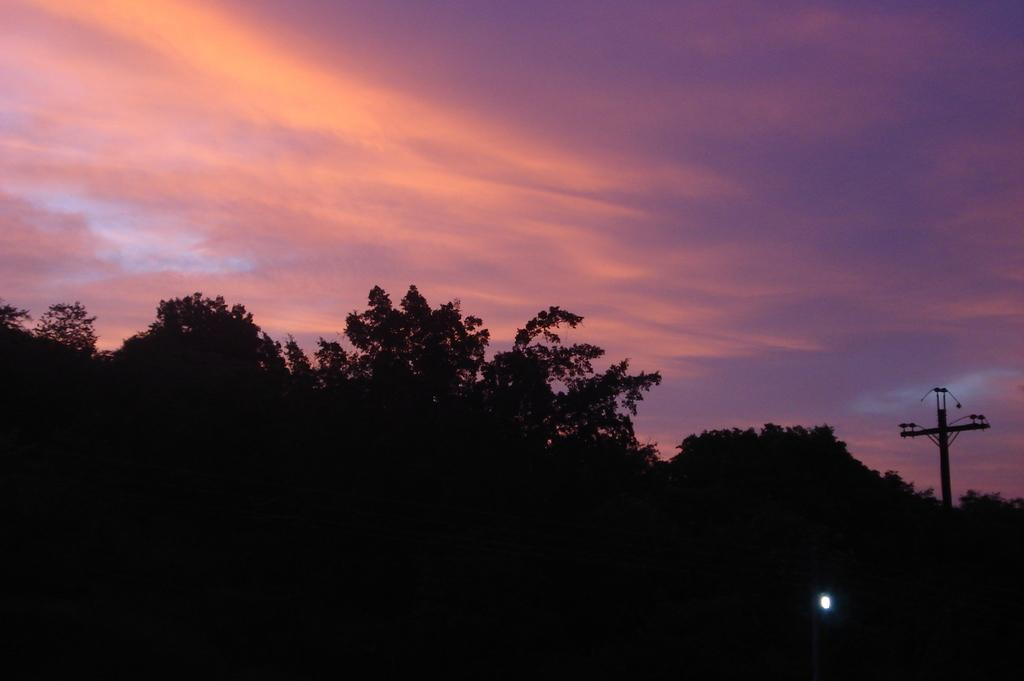What type of vegetation is at the bottom of the image? There are trees at the bottom of the image. What can be seen on the right side of the image? There is a light on the right side of the image. What is visible at the top of the image? The sky is visible at the top of the image. How many brains can be seen floating in the sky in the image? There are no brains visible in the image; only trees, a light, and the sky are present. Can you tell me what type of fish is swimming near the trees in the image? There are no fish present in the image; it features trees, a light, and the sky. 